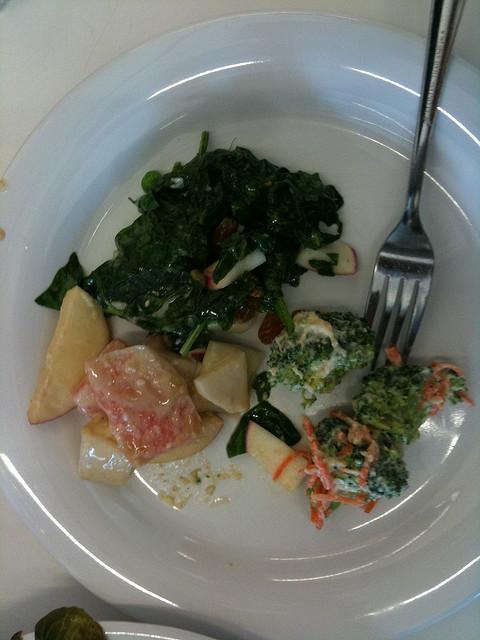How many broccolis are in the picture?
Give a very brief answer. 3. How many dogs are in the photo?
Give a very brief answer. 0. 